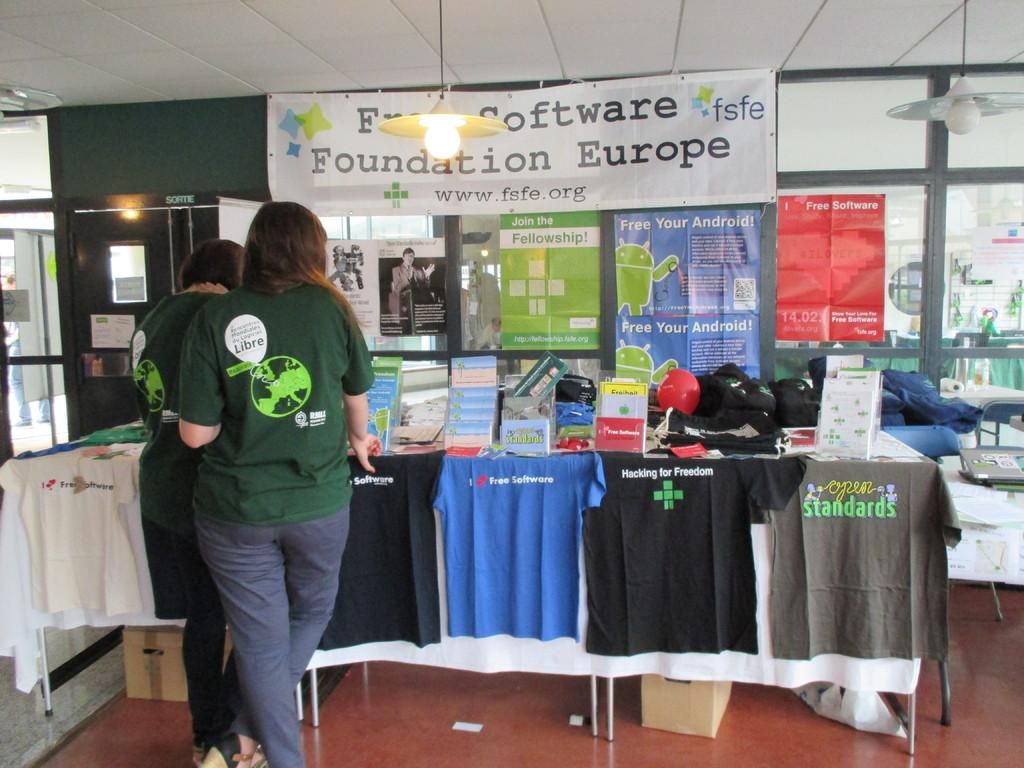<image>
Give a short and clear explanation of the subsequent image. People stand in line and look at shirts on a table for the Fun Sooftware Foundation of Europe. 